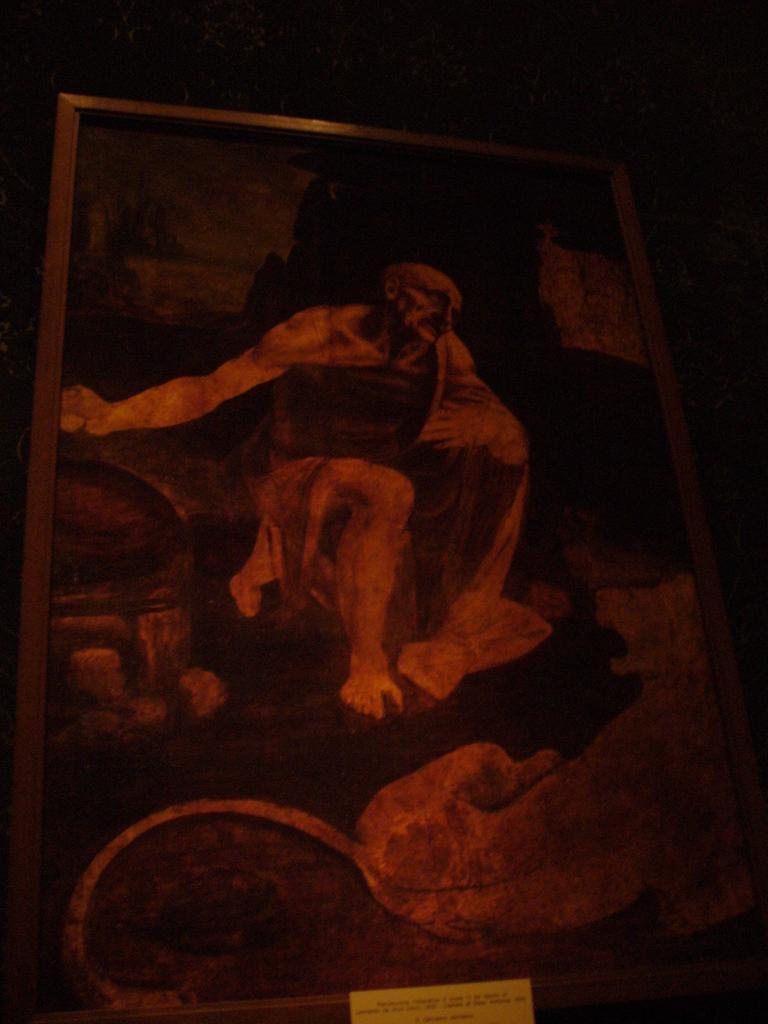Can you describe this image briefly? In this image we can see the painting of a person. And we can see the dark background. 